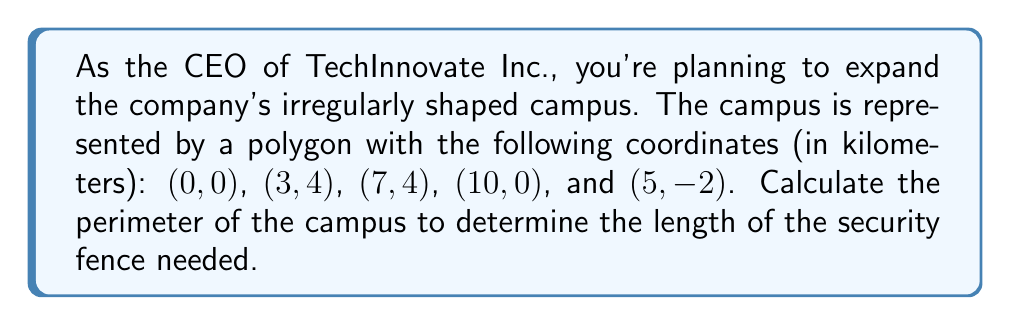Can you answer this question? Let's approach this step-by-step:

1) We need to calculate the distance between each pair of consecutive points and sum them up. We'll use the distance formula: 
   $$d = \sqrt{(x_2-x_1)^2 + (y_2-y_1)^2}$$

2) Calculate the distance between (0,0) and (3,4):
   $$d_1 = \sqrt{(3-0)^2 + (4-0)^2} = \sqrt{9 + 16} = 5\text{ km}$$

3) Distance between (3,4) and (7,4):
   $$d_2 = \sqrt{(7-3)^2 + (4-4)^2} = \sqrt{16 + 0} = 4\text{ km}$$

4) Distance between (7,4) and (10,0):
   $$d_3 = \sqrt{(10-7)^2 + (0-4)^2} = \sqrt{9 + 16} = 5\text{ km}$$

5) Distance between (10,0) and (5,-2):
   $$d_4 = \sqrt{(5-10)^2 + (-2-0)^2} = \sqrt{25 + 4} = \sqrt{29}\text{ km}$$

6) Distance between (5,-2) and (0,0):
   $$d_5 = \sqrt{(0-5)^2 + (0-(-2))^2} = \sqrt{25 + 4} = \sqrt{29}\text{ km}$$

7) The perimeter is the sum of all these distances:
   $$\text{Perimeter} = 5 + 4 + 5 + \sqrt{29} + \sqrt{29} = 14 + 2\sqrt{29}\text{ km}$$

[asy]
unitsize(20);
draw((0,0)--(3,4)--(7,4)--(10,0)--(5,-2)--cycle);
label("(0,0)", (0,0), SW);
label("(3,4)", (3,4), N);
label("(7,4)", (7,4), N);
label("(10,0)", (10,0), SE);
label("(5,-2)", (5,-2), S);
[/asy]
Answer: $14 + 2\sqrt{29}$ km 